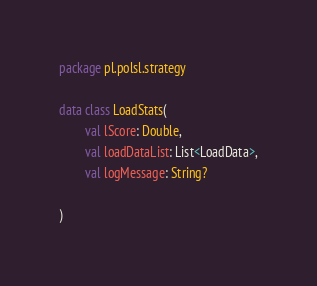Convert code to text. <code><loc_0><loc_0><loc_500><loc_500><_Kotlin_>package pl.polsl.strategy

data class LoadStats(
        val lScore: Double,
        val loadDataList: List<LoadData>,
        val logMessage: String?

)</code> 